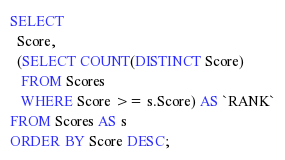<code> <loc_0><loc_0><loc_500><loc_500><_SQL_>SELECT
  Score,
  (SELECT COUNT(DISTINCT Score)
   FROM Scores
   WHERE Score >= s.Score) AS `RANK`
FROM Scores AS s
ORDER BY Score DESC;
</code> 